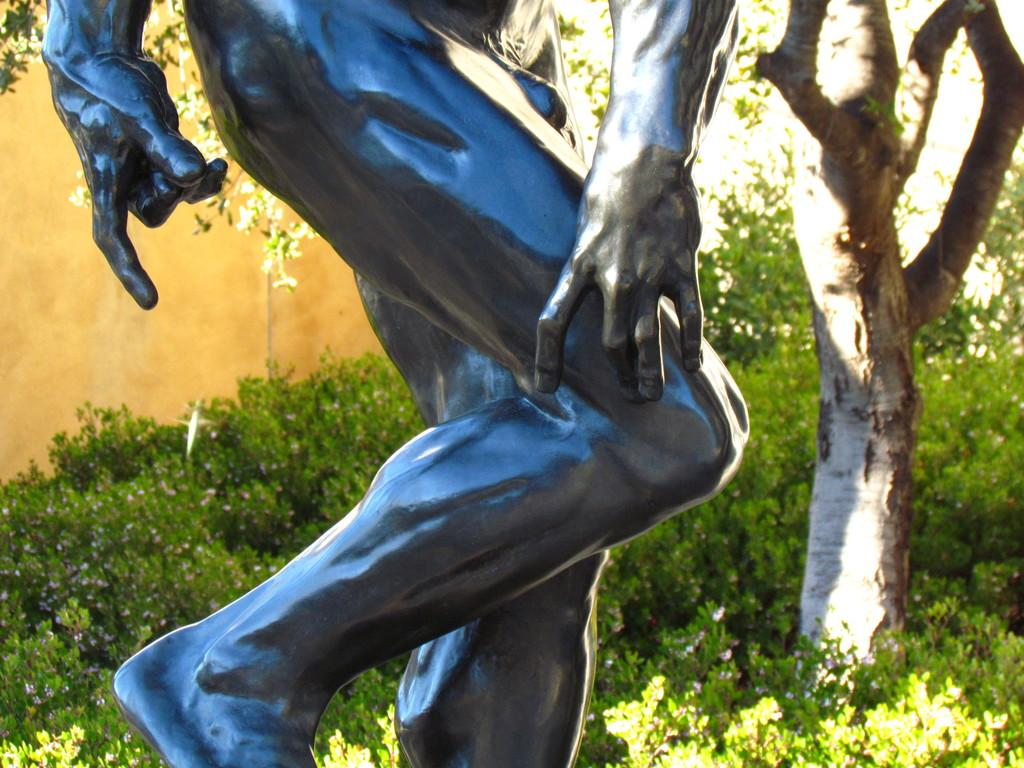What is the main subject of the image? There is a sculpture in the image. What other elements can be seen in the image? There are small plants and a tree in the image. What type of structure is present in the image? There is a wall in the image. Can you describe the river flowing near the sculpture in the image? There is no river present in the image; it only features a sculpture, small plants, a tree, and a wall. 